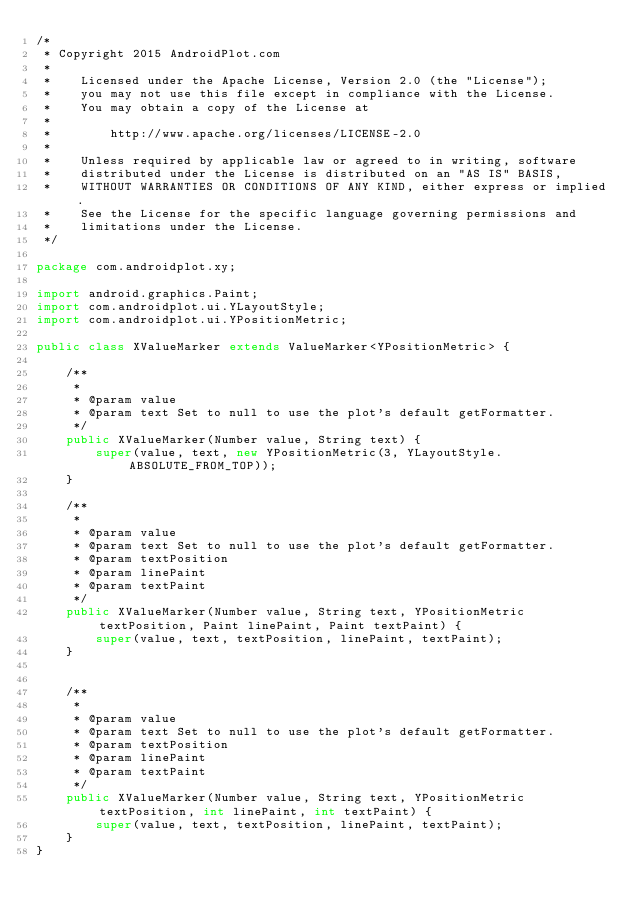<code> <loc_0><loc_0><loc_500><loc_500><_Java_>/*
 * Copyright 2015 AndroidPlot.com
 *
 *    Licensed under the Apache License, Version 2.0 (the "License");
 *    you may not use this file except in compliance with the License.
 *    You may obtain a copy of the License at
 *
 *        http://www.apache.org/licenses/LICENSE-2.0
 *
 *    Unless required by applicable law or agreed to in writing, software
 *    distributed under the License is distributed on an "AS IS" BASIS,
 *    WITHOUT WARRANTIES OR CONDITIONS OF ANY KIND, either express or implied.
 *    See the License for the specific language governing permissions and
 *    limitations under the License.
 */

package com.androidplot.xy;

import android.graphics.Paint;
import com.androidplot.ui.YLayoutStyle;
import com.androidplot.ui.YPositionMetric;

public class XValueMarker extends ValueMarker<YPositionMetric> {

    /**
     *
     * @param value
     * @param text Set to null to use the plot's default getFormatter.
     */
    public XValueMarker(Number value, String text) {
        super(value, text, new YPositionMetric(3, YLayoutStyle.ABSOLUTE_FROM_TOP));
    }

    /**
     *
     * @param value
     * @param text Set to null to use the plot's default getFormatter.
     * @param textPosition
     * @param linePaint
     * @param textPaint
     */
    public XValueMarker(Number value, String text, YPositionMetric textPosition, Paint linePaint, Paint textPaint) {
        super(value, text, textPosition, linePaint, textPaint);
    }


    /**
     *
     * @param value
     * @param text Set to null to use the plot's default getFormatter.
     * @param textPosition
     * @param linePaint
     * @param textPaint
     */
    public XValueMarker(Number value, String text, YPositionMetric textPosition, int linePaint, int textPaint) {
        super(value, text, textPosition, linePaint, textPaint);
    }
}
</code> 